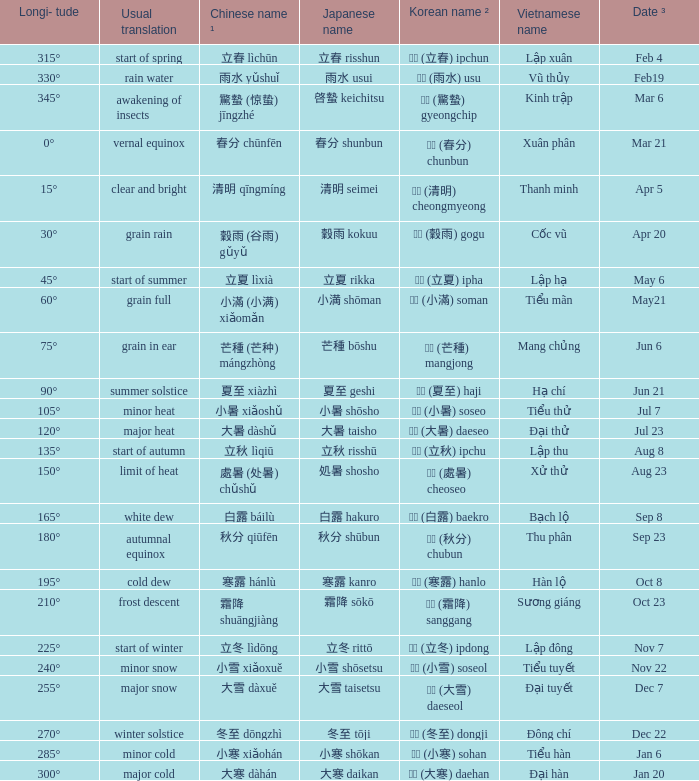Which Japanese name has a Korean name ² of 경칩 (驚蟄) gyeongchip? 啓蟄 keichitsu. 